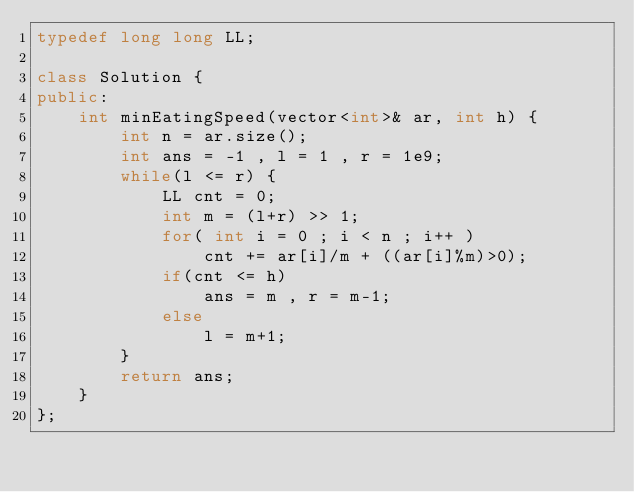<code> <loc_0><loc_0><loc_500><loc_500><_C++_>typedef long long LL;

class Solution {
public:
    int minEatingSpeed(vector<int>& ar, int h) {
        int n = ar.size();
        int ans = -1 , l = 1 , r = 1e9;
        while(l <= r) {
            LL cnt = 0;
            int m = (l+r) >> 1;
            for( int i = 0 ; i < n ; i++ )
                cnt += ar[i]/m + ((ar[i]%m)>0);
            if(cnt <= h)
                ans = m , r = m-1;
            else
                l = m+1;
        }
        return ans;
    }
};</code> 